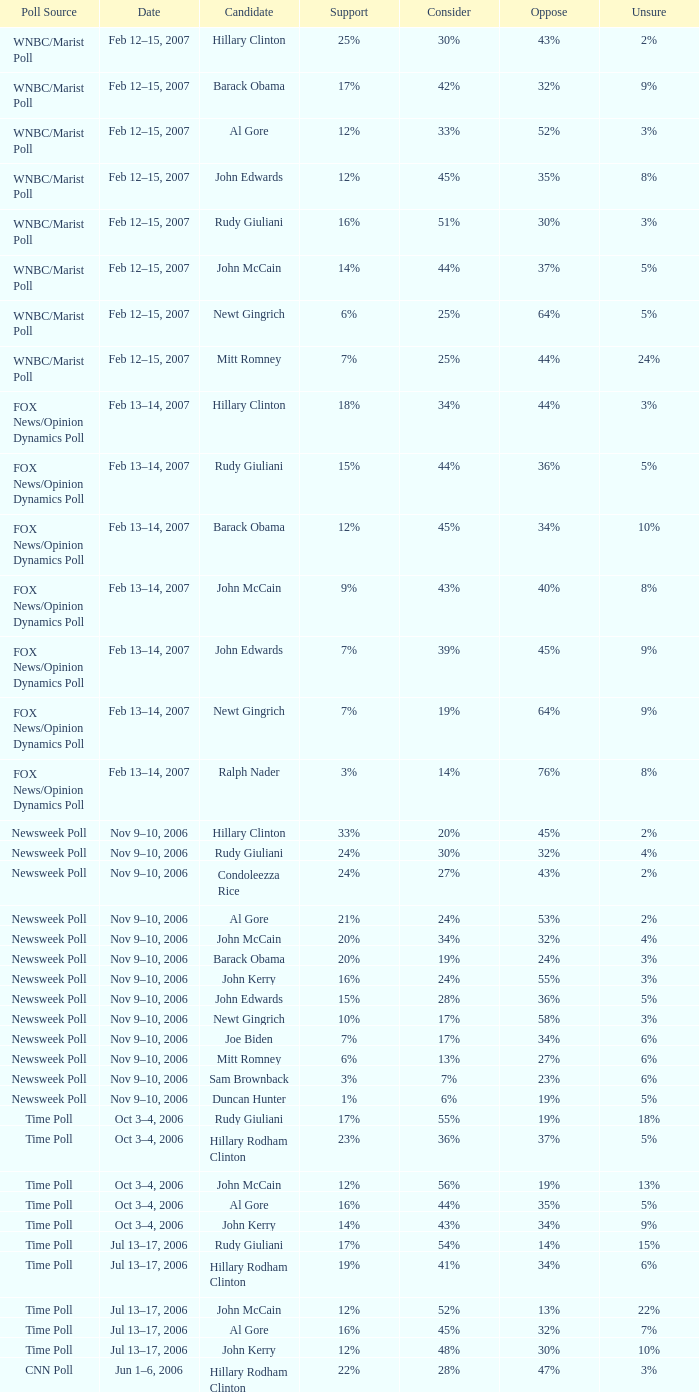Based on the time poll that indicated 6% of people were uncertain, what proportion of individuals opposed the candidate? 34%. Can you parse all the data within this table? {'header': ['Poll Source', 'Date', 'Candidate', 'Support', 'Consider', 'Oppose', 'Unsure'], 'rows': [['WNBC/Marist Poll', 'Feb 12–15, 2007', 'Hillary Clinton', '25%', '30%', '43%', '2%'], ['WNBC/Marist Poll', 'Feb 12–15, 2007', 'Barack Obama', '17%', '42%', '32%', '9%'], ['WNBC/Marist Poll', 'Feb 12–15, 2007', 'Al Gore', '12%', '33%', '52%', '3%'], ['WNBC/Marist Poll', 'Feb 12–15, 2007', 'John Edwards', '12%', '45%', '35%', '8%'], ['WNBC/Marist Poll', 'Feb 12–15, 2007', 'Rudy Giuliani', '16%', '51%', '30%', '3%'], ['WNBC/Marist Poll', 'Feb 12–15, 2007', 'John McCain', '14%', '44%', '37%', '5%'], ['WNBC/Marist Poll', 'Feb 12–15, 2007', 'Newt Gingrich', '6%', '25%', '64%', '5%'], ['WNBC/Marist Poll', 'Feb 12–15, 2007', 'Mitt Romney', '7%', '25%', '44%', '24%'], ['FOX News/Opinion Dynamics Poll', 'Feb 13–14, 2007', 'Hillary Clinton', '18%', '34%', '44%', '3%'], ['FOX News/Opinion Dynamics Poll', 'Feb 13–14, 2007', 'Rudy Giuliani', '15%', '44%', '36%', '5%'], ['FOX News/Opinion Dynamics Poll', 'Feb 13–14, 2007', 'Barack Obama', '12%', '45%', '34%', '10%'], ['FOX News/Opinion Dynamics Poll', 'Feb 13–14, 2007', 'John McCain', '9%', '43%', '40%', '8%'], ['FOX News/Opinion Dynamics Poll', 'Feb 13–14, 2007', 'John Edwards', '7%', '39%', '45%', '9%'], ['FOX News/Opinion Dynamics Poll', 'Feb 13–14, 2007', 'Newt Gingrich', '7%', '19%', '64%', '9%'], ['FOX News/Opinion Dynamics Poll', 'Feb 13–14, 2007', 'Ralph Nader', '3%', '14%', '76%', '8%'], ['Newsweek Poll', 'Nov 9–10, 2006', 'Hillary Clinton', '33%', '20%', '45%', '2%'], ['Newsweek Poll', 'Nov 9–10, 2006', 'Rudy Giuliani', '24%', '30%', '32%', '4%'], ['Newsweek Poll', 'Nov 9–10, 2006', 'Condoleezza Rice', '24%', '27%', '43%', '2%'], ['Newsweek Poll', 'Nov 9–10, 2006', 'Al Gore', '21%', '24%', '53%', '2%'], ['Newsweek Poll', 'Nov 9–10, 2006', 'John McCain', '20%', '34%', '32%', '4%'], ['Newsweek Poll', 'Nov 9–10, 2006', 'Barack Obama', '20%', '19%', '24%', '3%'], ['Newsweek Poll', 'Nov 9–10, 2006', 'John Kerry', '16%', '24%', '55%', '3%'], ['Newsweek Poll', 'Nov 9–10, 2006', 'John Edwards', '15%', '28%', '36%', '5%'], ['Newsweek Poll', 'Nov 9–10, 2006', 'Newt Gingrich', '10%', '17%', '58%', '3%'], ['Newsweek Poll', 'Nov 9–10, 2006', 'Joe Biden', '7%', '17%', '34%', '6%'], ['Newsweek Poll', 'Nov 9–10, 2006', 'Mitt Romney', '6%', '13%', '27%', '6%'], ['Newsweek Poll', 'Nov 9–10, 2006', 'Sam Brownback', '3%', '7%', '23%', '6%'], ['Newsweek Poll', 'Nov 9–10, 2006', 'Duncan Hunter', '1%', '6%', '19%', '5%'], ['Time Poll', 'Oct 3–4, 2006', 'Rudy Giuliani', '17%', '55%', '19%', '18%'], ['Time Poll', 'Oct 3–4, 2006', 'Hillary Rodham Clinton', '23%', '36%', '37%', '5%'], ['Time Poll', 'Oct 3–4, 2006', 'John McCain', '12%', '56%', '19%', '13%'], ['Time Poll', 'Oct 3–4, 2006', 'Al Gore', '16%', '44%', '35%', '5%'], ['Time Poll', 'Oct 3–4, 2006', 'John Kerry', '14%', '43%', '34%', '9%'], ['Time Poll', 'Jul 13–17, 2006', 'Rudy Giuliani', '17%', '54%', '14%', '15%'], ['Time Poll', 'Jul 13–17, 2006', 'Hillary Rodham Clinton', '19%', '41%', '34%', '6%'], ['Time Poll', 'Jul 13–17, 2006', 'John McCain', '12%', '52%', '13%', '22%'], ['Time Poll', 'Jul 13–17, 2006', 'Al Gore', '16%', '45%', '32%', '7%'], ['Time Poll', 'Jul 13–17, 2006', 'John Kerry', '12%', '48%', '30%', '10%'], ['CNN Poll', 'Jun 1–6, 2006', 'Hillary Rodham Clinton', '22%', '28%', '47%', '3%'], ['CNN Poll', 'Jun 1–6, 2006', 'Al Gore', '17%', '32%', '48%', '3%'], ['CNN Poll', 'Jun 1–6, 2006', 'John Kerry', '14%', '35%', '47%', '4%'], ['CNN Poll', 'Jun 1–6, 2006', 'Rudolph Giuliani', '19%', '45%', '30%', '6%'], ['CNN Poll', 'Jun 1–6, 2006', 'John McCain', '12%', '48%', '34%', '6%'], ['CNN Poll', 'Jun 1–6, 2006', 'Jeb Bush', '9%', '26%', '63%', '2%'], ['ABC News/Washington Post Poll', 'May 11–15, 2006', 'Hillary Clinton', '19%', '38%', '42%', '1%'], ['ABC News/Washington Post Poll', 'May 11–15, 2006', 'John McCain', '9%', '57%', '28%', '6%'], ['FOX News/Opinion Dynamics Poll', 'Feb 7–8, 2006', 'Hillary Clinton', '35%', '19%', '44%', '2%'], ['FOX News/Opinion Dynamics Poll', 'Feb 7–8, 2006', 'Rudy Giuliani', '33%', '38%', '24%', '6%'], ['FOX News/Opinion Dynamics Poll', 'Feb 7–8, 2006', 'John McCain', '30%', '40%', '22%', '7%'], ['FOX News/Opinion Dynamics Poll', 'Feb 7–8, 2006', 'John Kerry', '29%', '23%', '45%', '3%'], ['FOX News/Opinion Dynamics Poll', 'Feb 7–8, 2006', 'Condoleezza Rice', '14%', '38%', '46%', '3%'], ['CNN/USA Today/Gallup Poll', 'Jan 20–22, 2006', 'Hillary Rodham Clinton', '16%', '32%', '51%', '1%'], ['Diageo/Hotline Poll', 'Nov 11–15, 2005', 'John McCain', '23%', '46%', '15%', '15%'], ['CNN/USA Today/Gallup Poll', 'May 20–22, 2005', 'Hillary Rodham Clinton', '28%', '31%', '40%', '1%'], ['CNN/USA Today/Gallup Poll', 'Jun 9–10, 2003', 'Hillary Rodham Clinton', '20%', '33%', '45%', '2%']]} 